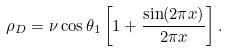Convert formula to latex. <formula><loc_0><loc_0><loc_500><loc_500>\rho _ { D } = \nu \cos \theta _ { 1 } \left [ 1 + \frac { \sin ( 2 \pi x ) } { 2 \pi x } \right ] .</formula> 